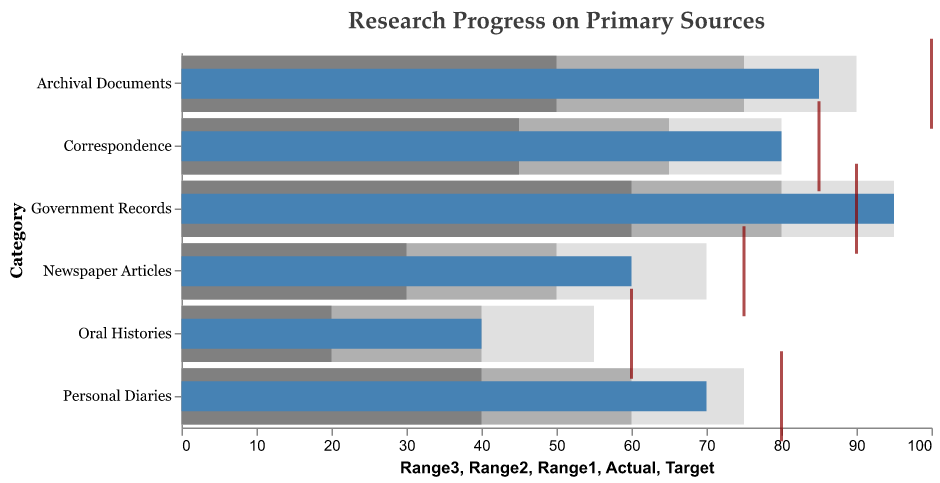What is the title of the chart? The title is at the top of the chart and reads "Research Progress on Primary Sources".
Answer: Research Progress on Primary Sources How many categories of primary sources are displayed in the chart? There are bars for each category, totaling six categories: Archival Documents, Personal Diaries, Government Records, Newspaper Articles, Oral Histories, Correspondence.
Answer: Six Which category has the highest actual research progress? By comparing the "Actual" values of each category, Government Records has the highest actual progress with 95.
Answer: Government Records Is the actual progress for Correspondence greater than its target? The Correspondence category has an actual value of 80 and a target of 85, thus actual progress is less than the target.
Answer: No Which category's actual progress most closely matches its target? By comparing the difference between actual and target values, Government Records has the smallest difference (actual is 95, target is 90).
Answer: Government Records What is the range of values for Archival Documents in terms of three ranges shown in the chart? Archival Documents range1 is 50, range2 is 75, and range3 is 90. This can be seen on the chart by the stacked bars in grayscale.
Answer: 50, 75, 90 What is the difference between actual progress and the target for Personal Diaries? Personal Diaries has an actual value of 70 and a target of 80. The difference is 80 - 70.
Answer: 10 Among all categories, which has the lowest actual progress? The category with the lowest actual value, which is represented by a bar closest to zero, is Oral Histories at 40.
Answer: Oral Histories Does Newspaper Articles' actual progress fall within the best performance range (Range3)? Newspaper Articles has an actual value of 60, and Range3 starts at 50 and ends at 70. Since 60 falls within this range, the progress is within the best performance range.
Answer: Yes How many categories have an actual progress lower than 60? By examining the "Actual" values, Oral Histories and Newspaper Articles have values less than 60.
Answer: Two 